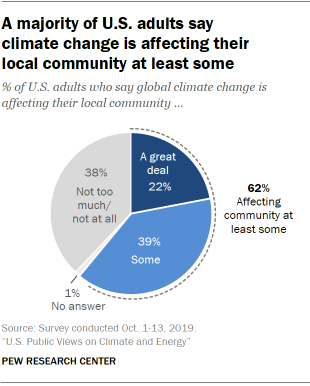List a handful of essential elements in this visual. The ratio between "Not too much/not at all" and "Some" is 0.9744... In the pie chart, the percentage represented by the "A" category is relatively large, making up approximately 22% of the total. 